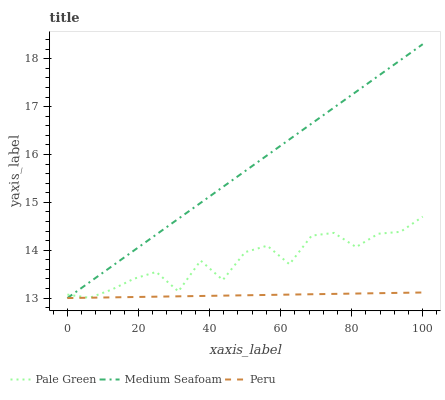Does Medium Seafoam have the minimum area under the curve?
Answer yes or no. No. Does Peru have the maximum area under the curve?
Answer yes or no. No. Is Medium Seafoam the smoothest?
Answer yes or no. No. Is Medium Seafoam the roughest?
Answer yes or no. No. Does Peru have the highest value?
Answer yes or no. No. 